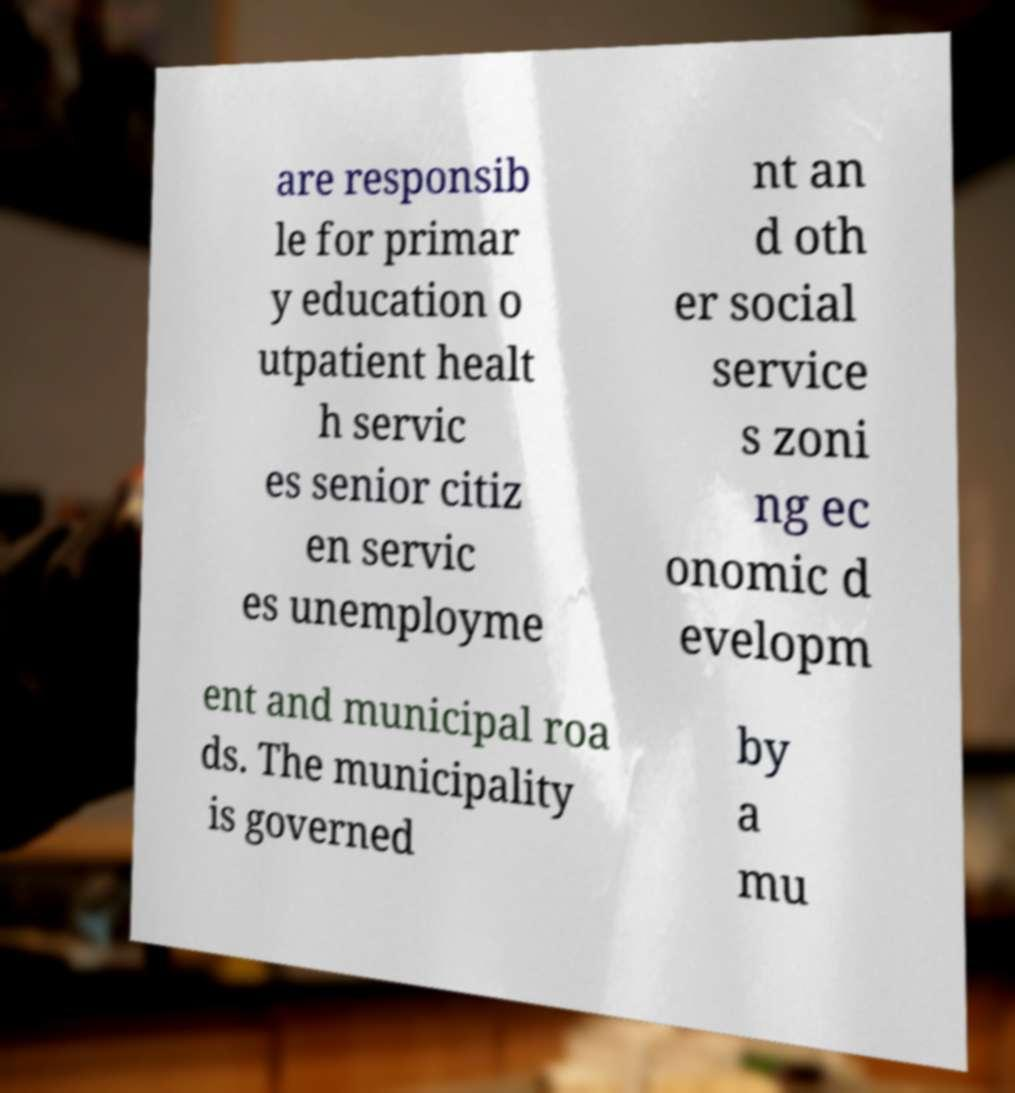Please read and relay the text visible in this image. What does it say? are responsib le for primar y education o utpatient healt h servic es senior citiz en servic es unemployme nt an d oth er social service s zoni ng ec onomic d evelopm ent and municipal roa ds. The municipality is governed by a mu 